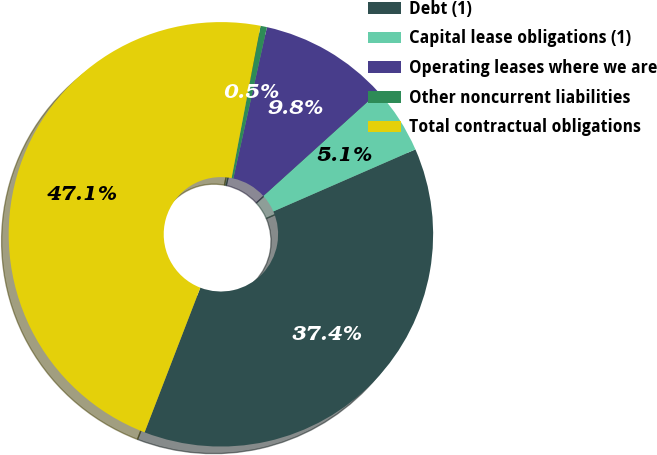Convert chart. <chart><loc_0><loc_0><loc_500><loc_500><pie_chart><fcel>Debt (1)<fcel>Capital lease obligations (1)<fcel>Operating leases where we are<fcel>Other noncurrent liabilities<fcel>Total contractual obligations<nl><fcel>37.41%<fcel>5.15%<fcel>9.82%<fcel>0.49%<fcel>47.14%<nl></chart> 